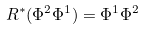<formula> <loc_0><loc_0><loc_500><loc_500>R ^ { * } ( \Phi ^ { 2 } \Phi ^ { 1 } ) = \Phi ^ { 1 } \Phi ^ { 2 } \</formula> 